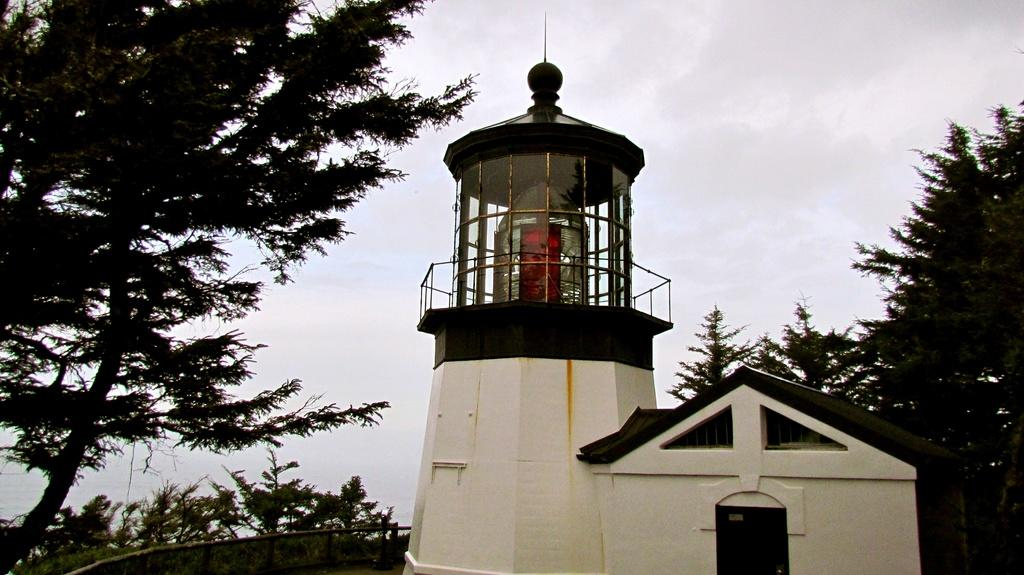What type of structure is present in the image? There is a house in the image. Are there any additional structures or features in the image? Yes, there is a small tower in the image. What can be seen surrounding the house and tower? There is a fence and trees in the image. What is visible in the background of the image? The sky is visible in the image. Where is the shelf located in the image? There is no shelf present in the image. What type of stick can be seen leaning against the house in the image? There is no stick present in the image. 